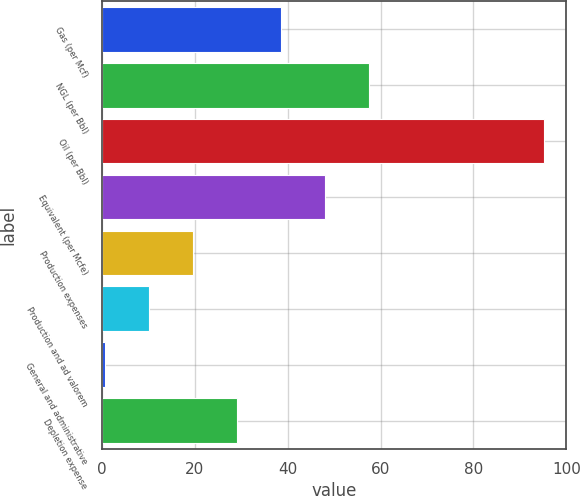<chart> <loc_0><loc_0><loc_500><loc_500><bar_chart><fcel>Gas (per Mcf)<fcel>NGL (per Bbl)<fcel>Oil (per Bbl)<fcel>Equivalent (per Mcfe)<fcel>Production expenses<fcel>Production and ad valorem<fcel>General and administrative<fcel>Depletion expense<nl><fcel>38.53<fcel>57.45<fcel>95.26<fcel>47.99<fcel>19.61<fcel>10.15<fcel>0.69<fcel>29.07<nl></chart> 